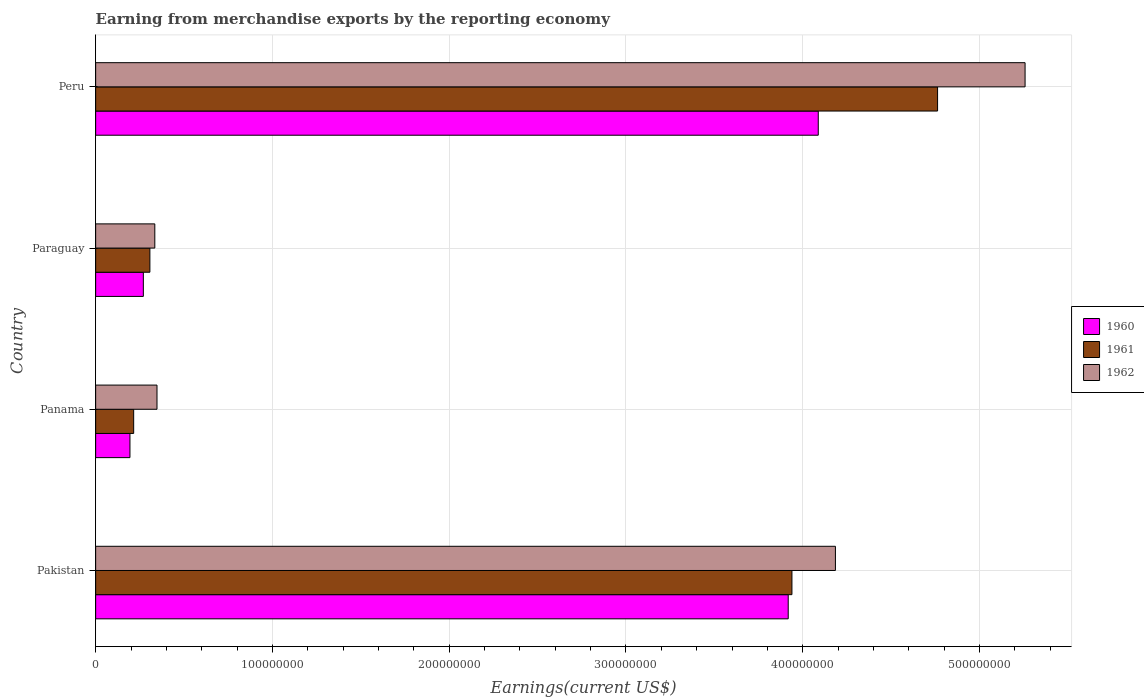How many different coloured bars are there?
Make the answer very short. 3. Are the number of bars per tick equal to the number of legend labels?
Provide a succinct answer. Yes. In how many cases, is the number of bars for a given country not equal to the number of legend labels?
Give a very brief answer. 0. What is the amount earned from merchandise exports in 1960 in Pakistan?
Offer a very short reply. 3.92e+08. Across all countries, what is the maximum amount earned from merchandise exports in 1960?
Ensure brevity in your answer.  4.09e+08. Across all countries, what is the minimum amount earned from merchandise exports in 1960?
Provide a short and direct response. 1.94e+07. In which country was the amount earned from merchandise exports in 1962 minimum?
Ensure brevity in your answer.  Paraguay. What is the total amount earned from merchandise exports in 1962 in the graph?
Ensure brevity in your answer.  1.01e+09. What is the difference between the amount earned from merchandise exports in 1961 in Panama and that in Paraguay?
Your response must be concise. -9.18e+06. What is the difference between the amount earned from merchandise exports in 1961 in Peru and the amount earned from merchandise exports in 1962 in Panama?
Keep it short and to the point. 4.42e+08. What is the average amount earned from merchandise exports in 1961 per country?
Offer a terse response. 2.31e+08. What is the difference between the amount earned from merchandise exports in 1961 and amount earned from merchandise exports in 1960 in Paraguay?
Your response must be concise. 3.70e+06. In how many countries, is the amount earned from merchandise exports in 1960 greater than 180000000 US$?
Give a very brief answer. 2. What is the ratio of the amount earned from merchandise exports in 1962 in Panama to that in Peru?
Keep it short and to the point. 0.07. What is the difference between the highest and the second highest amount earned from merchandise exports in 1960?
Keep it short and to the point. 1.70e+07. What is the difference between the highest and the lowest amount earned from merchandise exports in 1961?
Your answer should be very brief. 4.55e+08. Is the sum of the amount earned from merchandise exports in 1962 in Panama and Paraguay greater than the maximum amount earned from merchandise exports in 1961 across all countries?
Your response must be concise. No. What does the 1st bar from the top in Paraguay represents?
Your answer should be compact. 1962. Is it the case that in every country, the sum of the amount earned from merchandise exports in 1962 and amount earned from merchandise exports in 1961 is greater than the amount earned from merchandise exports in 1960?
Provide a succinct answer. Yes. How many countries are there in the graph?
Provide a short and direct response. 4. What is the difference between two consecutive major ticks on the X-axis?
Make the answer very short. 1.00e+08. Are the values on the major ticks of X-axis written in scientific E-notation?
Ensure brevity in your answer.  No. Does the graph contain any zero values?
Provide a short and direct response. No. Does the graph contain grids?
Offer a terse response. Yes. Where does the legend appear in the graph?
Provide a succinct answer. Center right. How are the legend labels stacked?
Provide a short and direct response. Vertical. What is the title of the graph?
Offer a very short reply. Earning from merchandise exports by the reporting economy. Does "1977" appear as one of the legend labels in the graph?
Offer a terse response. No. What is the label or title of the X-axis?
Offer a terse response. Earnings(current US$). What is the label or title of the Y-axis?
Keep it short and to the point. Country. What is the Earnings(current US$) in 1960 in Pakistan?
Keep it short and to the point. 3.92e+08. What is the Earnings(current US$) of 1961 in Pakistan?
Offer a very short reply. 3.94e+08. What is the Earnings(current US$) of 1962 in Pakistan?
Offer a very short reply. 4.18e+08. What is the Earnings(current US$) in 1960 in Panama?
Ensure brevity in your answer.  1.94e+07. What is the Earnings(current US$) of 1961 in Panama?
Your response must be concise. 2.15e+07. What is the Earnings(current US$) in 1962 in Panama?
Ensure brevity in your answer.  3.47e+07. What is the Earnings(current US$) in 1960 in Paraguay?
Keep it short and to the point. 2.70e+07. What is the Earnings(current US$) in 1961 in Paraguay?
Provide a short and direct response. 3.07e+07. What is the Earnings(current US$) of 1962 in Paraguay?
Your answer should be very brief. 3.35e+07. What is the Earnings(current US$) in 1960 in Peru?
Give a very brief answer. 4.09e+08. What is the Earnings(current US$) in 1961 in Peru?
Provide a succinct answer. 4.76e+08. What is the Earnings(current US$) of 1962 in Peru?
Your answer should be very brief. 5.26e+08. Across all countries, what is the maximum Earnings(current US$) of 1960?
Make the answer very short. 4.09e+08. Across all countries, what is the maximum Earnings(current US$) in 1961?
Make the answer very short. 4.76e+08. Across all countries, what is the maximum Earnings(current US$) in 1962?
Offer a terse response. 5.26e+08. Across all countries, what is the minimum Earnings(current US$) in 1960?
Keep it short and to the point. 1.94e+07. Across all countries, what is the minimum Earnings(current US$) of 1961?
Your response must be concise. 2.15e+07. Across all countries, what is the minimum Earnings(current US$) in 1962?
Provide a short and direct response. 3.35e+07. What is the total Earnings(current US$) in 1960 in the graph?
Keep it short and to the point. 8.47e+08. What is the total Earnings(current US$) in 1961 in the graph?
Offer a terse response. 9.22e+08. What is the total Earnings(current US$) in 1962 in the graph?
Offer a very short reply. 1.01e+09. What is the difference between the Earnings(current US$) in 1960 in Pakistan and that in Panama?
Offer a very short reply. 3.72e+08. What is the difference between the Earnings(current US$) in 1961 in Pakistan and that in Panama?
Ensure brevity in your answer.  3.72e+08. What is the difference between the Earnings(current US$) of 1962 in Pakistan and that in Panama?
Offer a terse response. 3.84e+08. What is the difference between the Earnings(current US$) of 1960 in Pakistan and that in Paraguay?
Provide a short and direct response. 3.65e+08. What is the difference between the Earnings(current US$) in 1961 in Pakistan and that in Paraguay?
Provide a succinct answer. 3.63e+08. What is the difference between the Earnings(current US$) in 1962 in Pakistan and that in Paraguay?
Provide a short and direct response. 3.85e+08. What is the difference between the Earnings(current US$) of 1960 in Pakistan and that in Peru?
Make the answer very short. -1.70e+07. What is the difference between the Earnings(current US$) in 1961 in Pakistan and that in Peru?
Ensure brevity in your answer.  -8.24e+07. What is the difference between the Earnings(current US$) of 1962 in Pakistan and that in Peru?
Provide a succinct answer. -1.07e+08. What is the difference between the Earnings(current US$) in 1960 in Panama and that in Paraguay?
Give a very brief answer. -7.58e+06. What is the difference between the Earnings(current US$) of 1961 in Panama and that in Paraguay?
Give a very brief answer. -9.18e+06. What is the difference between the Earnings(current US$) of 1962 in Panama and that in Paraguay?
Offer a terse response. 1.23e+06. What is the difference between the Earnings(current US$) of 1960 in Panama and that in Peru?
Give a very brief answer. -3.89e+08. What is the difference between the Earnings(current US$) in 1961 in Panama and that in Peru?
Your response must be concise. -4.55e+08. What is the difference between the Earnings(current US$) in 1962 in Panama and that in Peru?
Offer a terse response. -4.91e+08. What is the difference between the Earnings(current US$) of 1960 in Paraguay and that in Peru?
Offer a very short reply. -3.82e+08. What is the difference between the Earnings(current US$) in 1961 in Paraguay and that in Peru?
Keep it short and to the point. -4.46e+08. What is the difference between the Earnings(current US$) in 1962 in Paraguay and that in Peru?
Your answer should be very brief. -4.92e+08. What is the difference between the Earnings(current US$) in 1960 in Pakistan and the Earnings(current US$) in 1961 in Panama?
Your answer should be very brief. 3.70e+08. What is the difference between the Earnings(current US$) of 1960 in Pakistan and the Earnings(current US$) of 1962 in Panama?
Your response must be concise. 3.57e+08. What is the difference between the Earnings(current US$) in 1961 in Pakistan and the Earnings(current US$) in 1962 in Panama?
Make the answer very short. 3.59e+08. What is the difference between the Earnings(current US$) in 1960 in Pakistan and the Earnings(current US$) in 1961 in Paraguay?
Offer a very short reply. 3.61e+08. What is the difference between the Earnings(current US$) in 1960 in Pakistan and the Earnings(current US$) in 1962 in Paraguay?
Give a very brief answer. 3.58e+08. What is the difference between the Earnings(current US$) of 1961 in Pakistan and the Earnings(current US$) of 1962 in Paraguay?
Your response must be concise. 3.60e+08. What is the difference between the Earnings(current US$) of 1960 in Pakistan and the Earnings(current US$) of 1961 in Peru?
Your answer should be compact. -8.45e+07. What is the difference between the Earnings(current US$) in 1960 in Pakistan and the Earnings(current US$) in 1962 in Peru?
Offer a very short reply. -1.34e+08. What is the difference between the Earnings(current US$) in 1961 in Pakistan and the Earnings(current US$) in 1962 in Peru?
Keep it short and to the point. -1.32e+08. What is the difference between the Earnings(current US$) of 1960 in Panama and the Earnings(current US$) of 1961 in Paraguay?
Provide a succinct answer. -1.13e+07. What is the difference between the Earnings(current US$) of 1960 in Panama and the Earnings(current US$) of 1962 in Paraguay?
Your response must be concise. -1.41e+07. What is the difference between the Earnings(current US$) in 1961 in Panama and the Earnings(current US$) in 1962 in Paraguay?
Give a very brief answer. -1.20e+07. What is the difference between the Earnings(current US$) of 1960 in Panama and the Earnings(current US$) of 1961 in Peru?
Offer a very short reply. -4.57e+08. What is the difference between the Earnings(current US$) of 1960 in Panama and the Earnings(current US$) of 1962 in Peru?
Provide a short and direct response. -5.06e+08. What is the difference between the Earnings(current US$) in 1961 in Panama and the Earnings(current US$) in 1962 in Peru?
Ensure brevity in your answer.  -5.04e+08. What is the difference between the Earnings(current US$) of 1960 in Paraguay and the Earnings(current US$) of 1961 in Peru?
Make the answer very short. -4.49e+08. What is the difference between the Earnings(current US$) of 1960 in Paraguay and the Earnings(current US$) of 1962 in Peru?
Provide a short and direct response. -4.99e+08. What is the difference between the Earnings(current US$) of 1961 in Paraguay and the Earnings(current US$) of 1962 in Peru?
Ensure brevity in your answer.  -4.95e+08. What is the average Earnings(current US$) in 1960 per country?
Give a very brief answer. 2.12e+08. What is the average Earnings(current US$) of 1961 per country?
Ensure brevity in your answer.  2.31e+08. What is the average Earnings(current US$) of 1962 per country?
Your answer should be very brief. 2.53e+08. What is the difference between the Earnings(current US$) in 1960 and Earnings(current US$) in 1961 in Pakistan?
Your answer should be compact. -2.10e+06. What is the difference between the Earnings(current US$) in 1960 and Earnings(current US$) in 1962 in Pakistan?
Your response must be concise. -2.67e+07. What is the difference between the Earnings(current US$) in 1961 and Earnings(current US$) in 1962 in Pakistan?
Offer a terse response. -2.46e+07. What is the difference between the Earnings(current US$) in 1960 and Earnings(current US$) in 1961 in Panama?
Offer a very short reply. -2.10e+06. What is the difference between the Earnings(current US$) in 1960 and Earnings(current US$) in 1962 in Panama?
Provide a short and direct response. -1.53e+07. What is the difference between the Earnings(current US$) in 1961 and Earnings(current US$) in 1962 in Panama?
Your response must be concise. -1.32e+07. What is the difference between the Earnings(current US$) in 1960 and Earnings(current US$) in 1961 in Paraguay?
Offer a terse response. -3.70e+06. What is the difference between the Earnings(current US$) in 1960 and Earnings(current US$) in 1962 in Paraguay?
Offer a very short reply. -6.49e+06. What is the difference between the Earnings(current US$) in 1961 and Earnings(current US$) in 1962 in Paraguay?
Provide a succinct answer. -2.79e+06. What is the difference between the Earnings(current US$) of 1960 and Earnings(current US$) of 1961 in Peru?
Make the answer very short. -6.75e+07. What is the difference between the Earnings(current US$) in 1960 and Earnings(current US$) in 1962 in Peru?
Your answer should be very brief. -1.17e+08. What is the difference between the Earnings(current US$) of 1961 and Earnings(current US$) of 1962 in Peru?
Ensure brevity in your answer.  -4.95e+07. What is the ratio of the Earnings(current US$) of 1960 in Pakistan to that in Panama?
Make the answer very short. 20.2. What is the ratio of the Earnings(current US$) of 1961 in Pakistan to that in Panama?
Provide a succinct answer. 18.32. What is the ratio of the Earnings(current US$) in 1962 in Pakistan to that in Panama?
Your answer should be compact. 12.06. What is the ratio of the Earnings(current US$) of 1960 in Pakistan to that in Paraguay?
Offer a very short reply. 14.52. What is the ratio of the Earnings(current US$) of 1961 in Pakistan to that in Paraguay?
Provide a short and direct response. 12.84. What is the ratio of the Earnings(current US$) of 1962 in Pakistan to that in Paraguay?
Keep it short and to the point. 12.5. What is the ratio of the Earnings(current US$) of 1960 in Pakistan to that in Peru?
Your answer should be very brief. 0.96. What is the ratio of the Earnings(current US$) of 1961 in Pakistan to that in Peru?
Your answer should be compact. 0.83. What is the ratio of the Earnings(current US$) in 1962 in Pakistan to that in Peru?
Your response must be concise. 0.8. What is the ratio of the Earnings(current US$) of 1960 in Panama to that in Paraguay?
Your answer should be compact. 0.72. What is the ratio of the Earnings(current US$) of 1961 in Panama to that in Paraguay?
Your answer should be compact. 0.7. What is the ratio of the Earnings(current US$) of 1962 in Panama to that in Paraguay?
Your answer should be very brief. 1.04. What is the ratio of the Earnings(current US$) in 1960 in Panama to that in Peru?
Your answer should be compact. 0.05. What is the ratio of the Earnings(current US$) in 1961 in Panama to that in Peru?
Provide a short and direct response. 0.05. What is the ratio of the Earnings(current US$) of 1962 in Panama to that in Peru?
Offer a terse response. 0.07. What is the ratio of the Earnings(current US$) in 1960 in Paraguay to that in Peru?
Offer a very short reply. 0.07. What is the ratio of the Earnings(current US$) in 1961 in Paraguay to that in Peru?
Your response must be concise. 0.06. What is the ratio of the Earnings(current US$) in 1962 in Paraguay to that in Peru?
Make the answer very short. 0.06. What is the difference between the highest and the second highest Earnings(current US$) in 1960?
Your response must be concise. 1.70e+07. What is the difference between the highest and the second highest Earnings(current US$) of 1961?
Offer a very short reply. 8.24e+07. What is the difference between the highest and the second highest Earnings(current US$) of 1962?
Your response must be concise. 1.07e+08. What is the difference between the highest and the lowest Earnings(current US$) in 1960?
Provide a short and direct response. 3.89e+08. What is the difference between the highest and the lowest Earnings(current US$) of 1961?
Make the answer very short. 4.55e+08. What is the difference between the highest and the lowest Earnings(current US$) of 1962?
Give a very brief answer. 4.92e+08. 